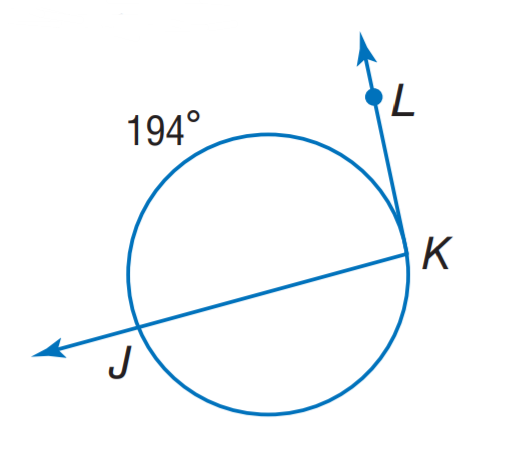Question: Find m \angle K.
Choices:
A. 97
B. 112
C. 166
D. 194
Answer with the letter. Answer: A 